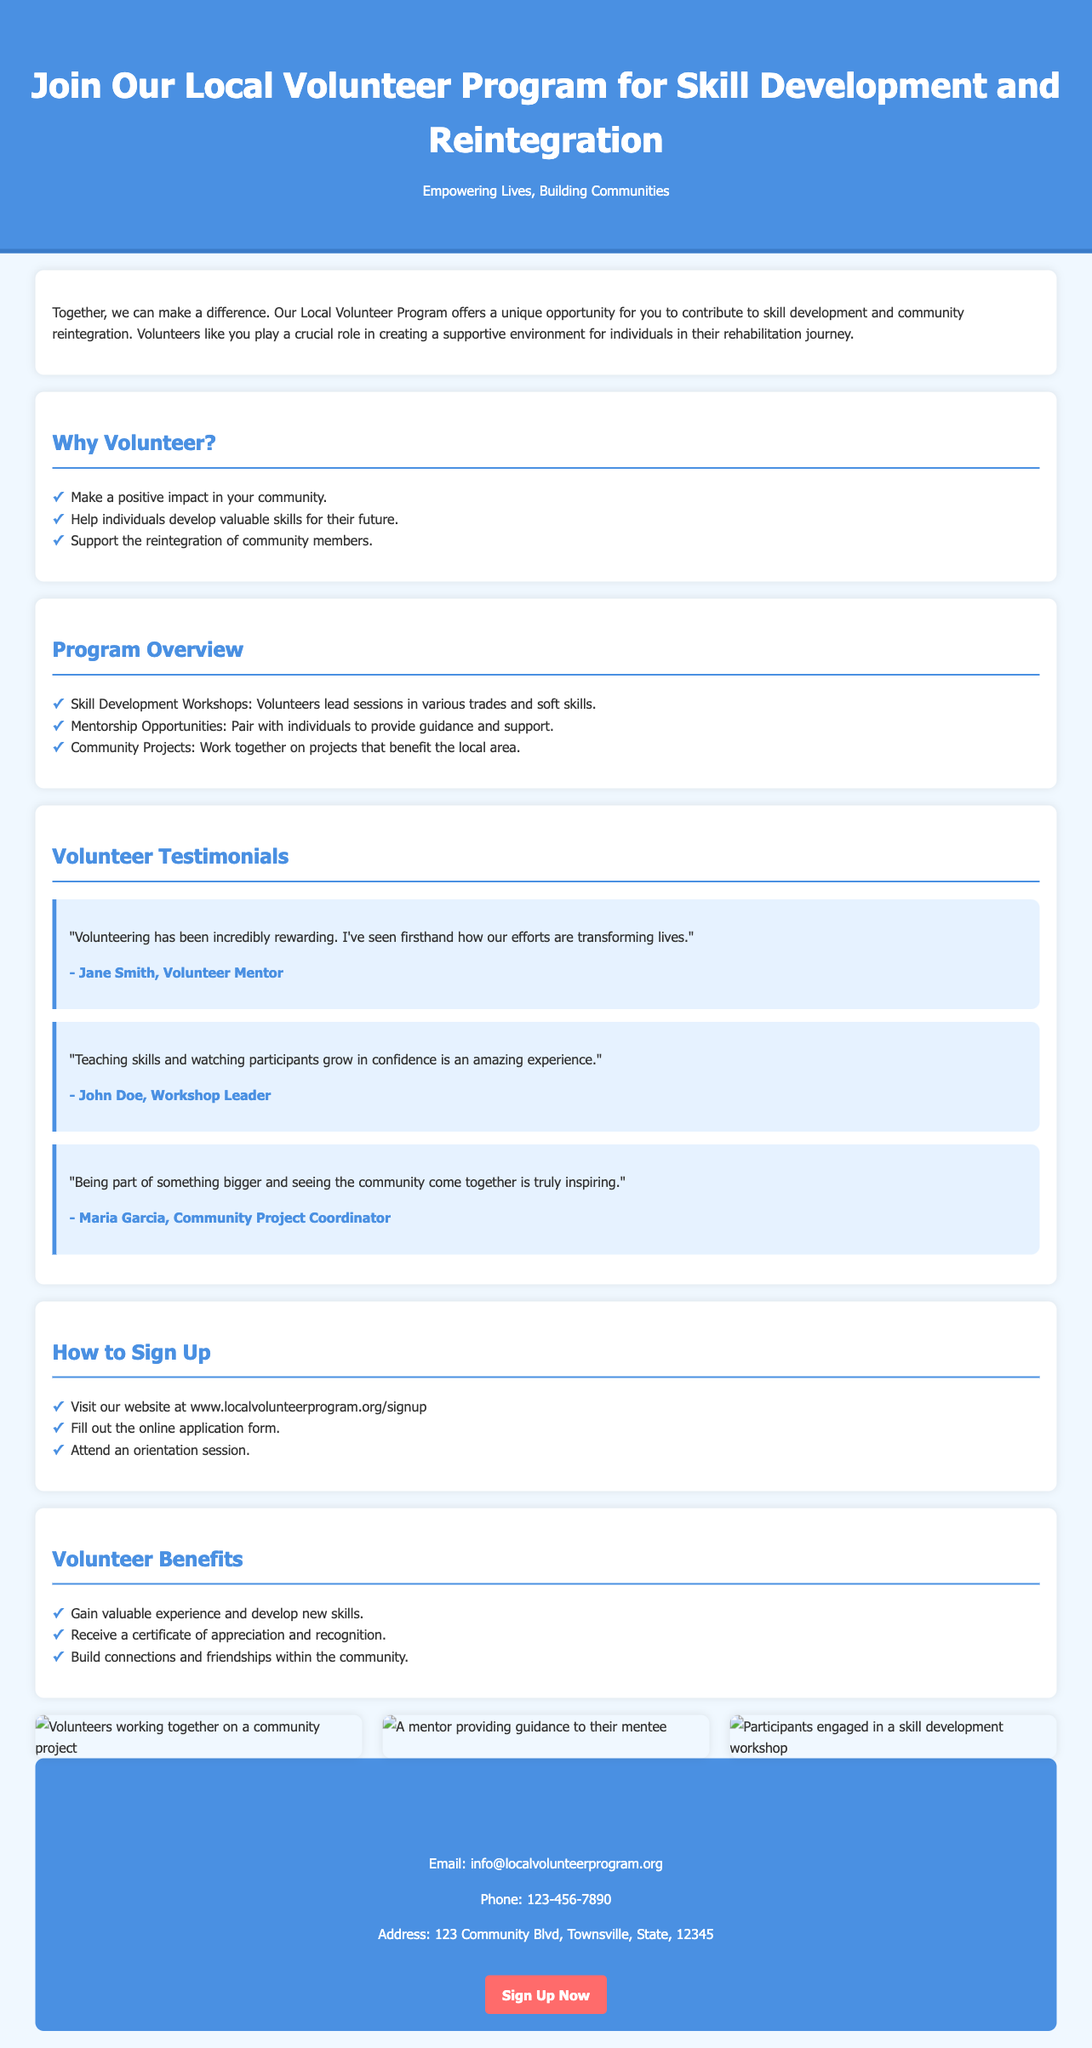what is the title of the program? The title of the program is prominently displayed at the top of the advertisement.
Answer: Join Our Local Volunteer Program for Skill Development and Reintegration how many testimonials are included? The advertisement lists the number of testimonials provided in the section dedicated to them.
Answer: Three what are the benefits of volunteering? The advertisement outlines several benefits associated with volunteering in a specific section.
Answer: Gain valuable experience and develop new skills, receive a certificate of appreciation and recognition, build connections and friendships within the community what is the first step to sign up? The sign-up process is detailed, highlighting the first action required to join the program.
Answer: Visit our website at www.localvolunteerprogram.org/signup who is the author of the first testimonial? The author's name of the first testimonial is mentioned directly after the quote.
Answer: Jane Smith which color is used for the header background? The header background color is specified in the advertisement's styling.
Answer: #4a90e2 (blue) what type of projects do volunteers work on? The advertisement specifies the type of projects volunteers will engage in within a program overview section.
Answer: Community Projects how can volunteers contact the program? The contact details are provided in a dedicated section for potential volunteers.
Answer: Email: info@localvolunteerprogram.org, Phone: 123-456-7890 